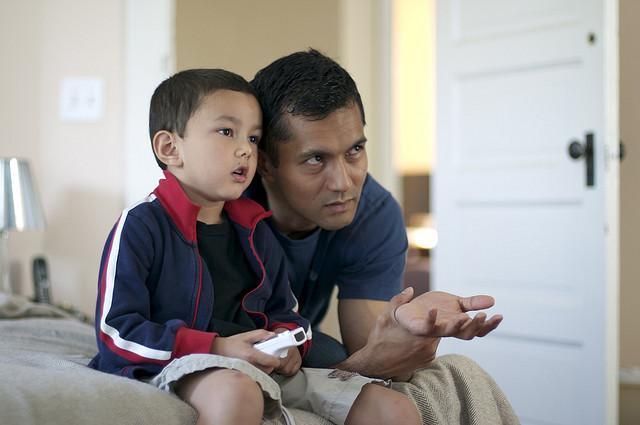What is the man helping the young boy do?
Make your selection and explain in format: 'Answer: answer
Rationale: rationale.'
Options: Play games, learn math, count, finish puzzle. Answer: play games.
Rationale: The man is helping the child use a motion controller for a video game. 